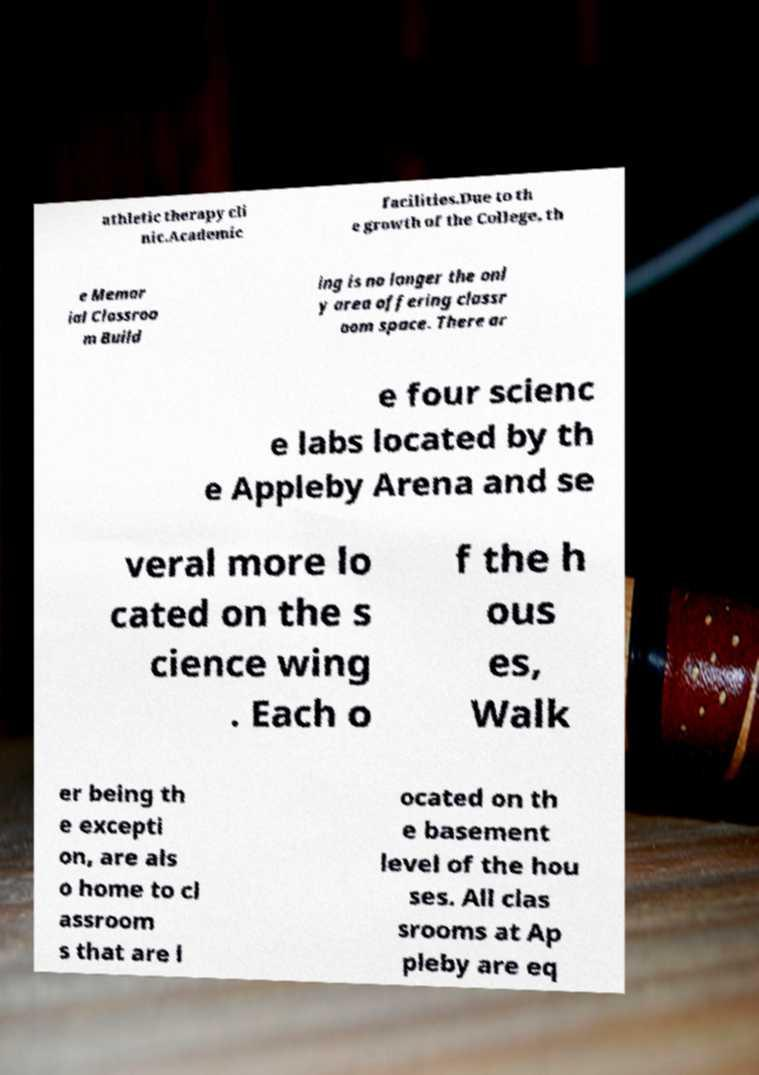I need the written content from this picture converted into text. Can you do that? athletic therapy cli nic.Academic facilities.Due to th e growth of the College, th e Memor ial Classroo m Build ing is no longer the onl y area offering classr oom space. There ar e four scienc e labs located by th e Appleby Arena and se veral more lo cated on the s cience wing . Each o f the h ous es, Walk er being th e excepti on, are als o home to cl assroom s that are l ocated on th e basement level of the hou ses. All clas srooms at Ap pleby are eq 